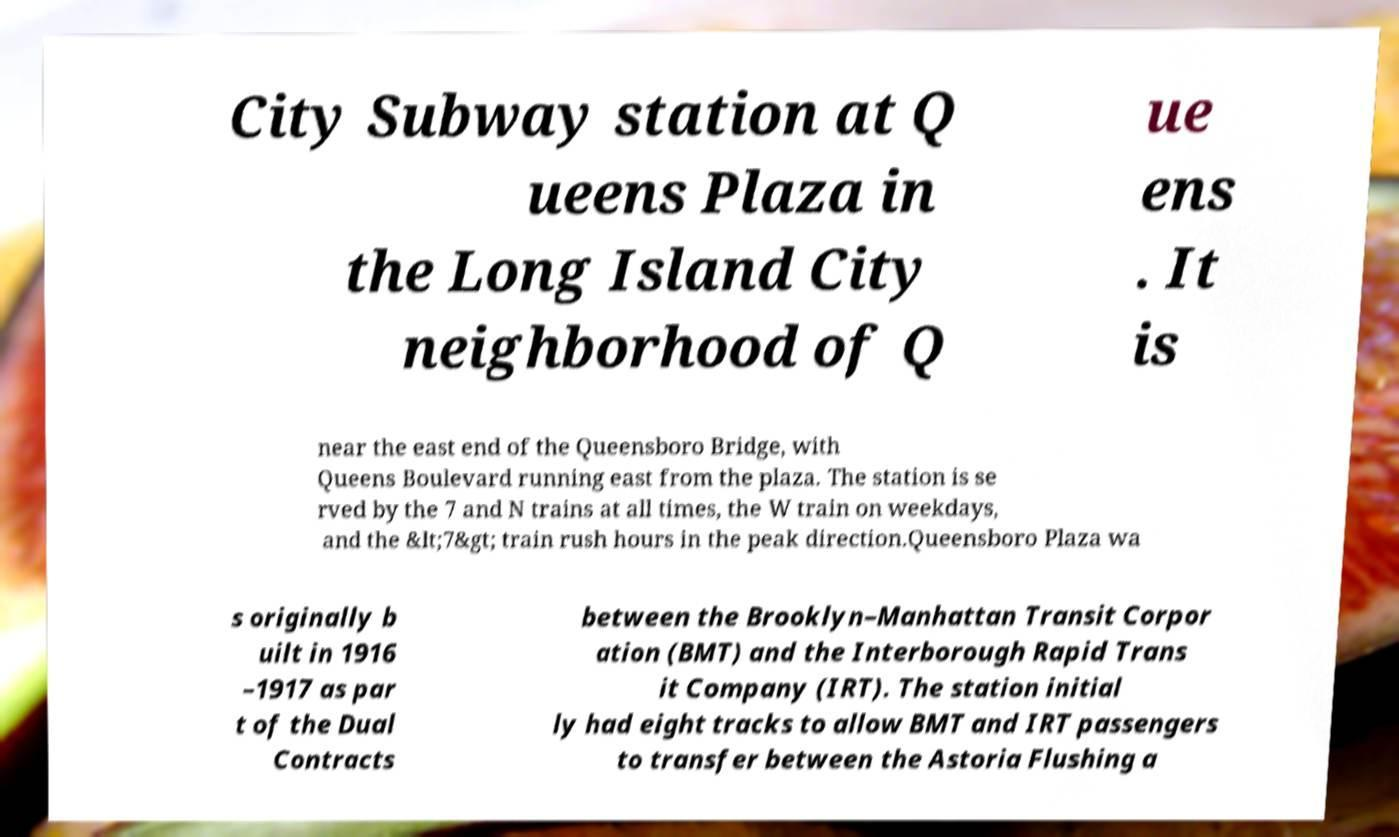I need the written content from this picture converted into text. Can you do that? City Subway station at Q ueens Plaza in the Long Island City neighborhood of Q ue ens . It is near the east end of the Queensboro Bridge, with Queens Boulevard running east from the plaza. The station is se rved by the 7 and N trains at all times, the W train on weekdays, and the &lt;7&gt; train rush hours in the peak direction.Queensboro Plaza wa s originally b uilt in 1916 –1917 as par t of the Dual Contracts between the Brooklyn–Manhattan Transit Corpor ation (BMT) and the Interborough Rapid Trans it Company (IRT). The station initial ly had eight tracks to allow BMT and IRT passengers to transfer between the Astoria Flushing a 